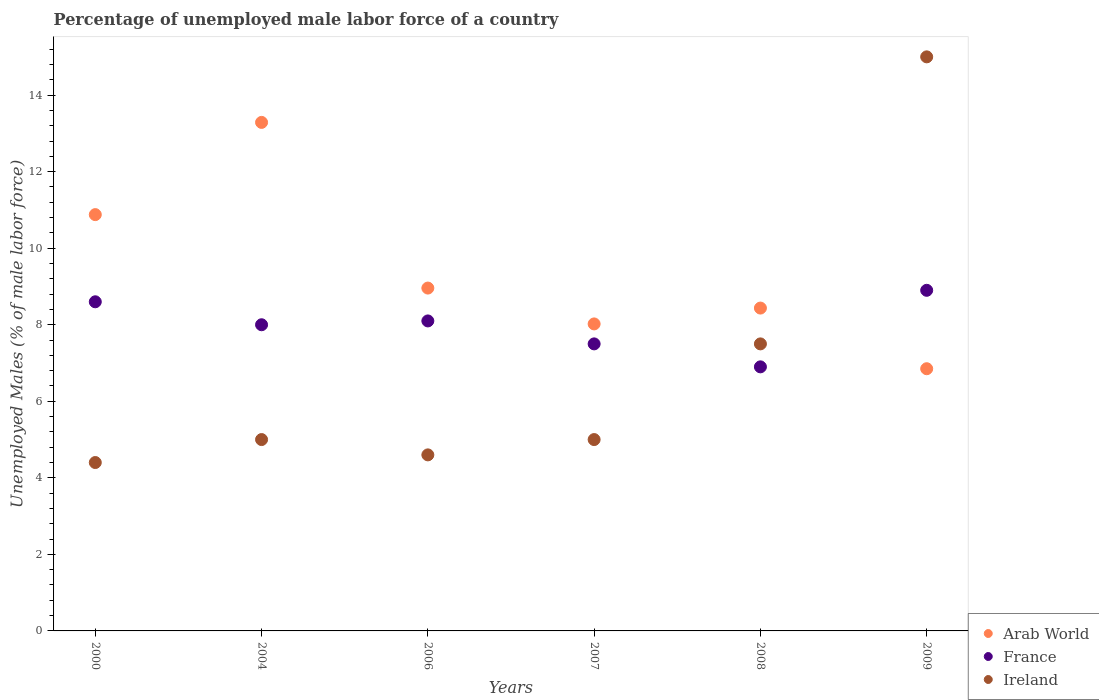How many different coloured dotlines are there?
Provide a short and direct response. 3. Is the number of dotlines equal to the number of legend labels?
Give a very brief answer. Yes. Across all years, what is the maximum percentage of unemployed male labor force in France?
Your answer should be very brief. 8.9. Across all years, what is the minimum percentage of unemployed male labor force in Ireland?
Ensure brevity in your answer.  4.4. In which year was the percentage of unemployed male labor force in Arab World maximum?
Your answer should be compact. 2004. In which year was the percentage of unemployed male labor force in Arab World minimum?
Provide a succinct answer. 2009. What is the total percentage of unemployed male labor force in Ireland in the graph?
Provide a short and direct response. 41.5. What is the difference between the percentage of unemployed male labor force in Ireland in 2000 and the percentage of unemployed male labor force in France in 2009?
Provide a short and direct response. -4.5. What is the average percentage of unemployed male labor force in Arab World per year?
Ensure brevity in your answer.  9.41. In the year 2007, what is the difference between the percentage of unemployed male labor force in Arab World and percentage of unemployed male labor force in Ireland?
Your response must be concise. 3.02. In how many years, is the percentage of unemployed male labor force in Arab World greater than 0.4 %?
Give a very brief answer. 6. What is the ratio of the percentage of unemployed male labor force in Ireland in 2004 to that in 2006?
Ensure brevity in your answer.  1.09. Is the percentage of unemployed male labor force in Ireland in 2008 less than that in 2009?
Provide a short and direct response. Yes. Is the difference between the percentage of unemployed male labor force in Arab World in 2006 and 2007 greater than the difference between the percentage of unemployed male labor force in Ireland in 2006 and 2007?
Provide a short and direct response. Yes. What is the difference between the highest and the second highest percentage of unemployed male labor force in Arab World?
Provide a succinct answer. 2.41. What is the difference between the highest and the lowest percentage of unemployed male labor force in Arab World?
Make the answer very short. 6.44. Is the sum of the percentage of unemployed male labor force in Arab World in 2000 and 2008 greater than the maximum percentage of unemployed male labor force in Ireland across all years?
Make the answer very short. Yes. Does the percentage of unemployed male labor force in France monotonically increase over the years?
Offer a terse response. No. Is the percentage of unemployed male labor force in France strictly greater than the percentage of unemployed male labor force in Ireland over the years?
Offer a very short reply. No. Is the percentage of unemployed male labor force in France strictly less than the percentage of unemployed male labor force in Ireland over the years?
Offer a very short reply. No. How many dotlines are there?
Keep it short and to the point. 3. What is the difference between two consecutive major ticks on the Y-axis?
Provide a short and direct response. 2. Where does the legend appear in the graph?
Provide a short and direct response. Bottom right. How many legend labels are there?
Your answer should be compact. 3. How are the legend labels stacked?
Ensure brevity in your answer.  Vertical. What is the title of the graph?
Provide a succinct answer. Percentage of unemployed male labor force of a country. What is the label or title of the X-axis?
Your response must be concise. Years. What is the label or title of the Y-axis?
Your response must be concise. Unemployed Males (% of male labor force). What is the Unemployed Males (% of male labor force) in Arab World in 2000?
Make the answer very short. 10.88. What is the Unemployed Males (% of male labor force) of France in 2000?
Make the answer very short. 8.6. What is the Unemployed Males (% of male labor force) of Ireland in 2000?
Make the answer very short. 4.4. What is the Unemployed Males (% of male labor force) of Arab World in 2004?
Offer a very short reply. 13.29. What is the Unemployed Males (% of male labor force) in France in 2004?
Your response must be concise. 8. What is the Unemployed Males (% of male labor force) in Ireland in 2004?
Offer a very short reply. 5. What is the Unemployed Males (% of male labor force) in Arab World in 2006?
Offer a terse response. 8.96. What is the Unemployed Males (% of male labor force) in France in 2006?
Your response must be concise. 8.1. What is the Unemployed Males (% of male labor force) in Ireland in 2006?
Offer a terse response. 4.6. What is the Unemployed Males (% of male labor force) of Arab World in 2007?
Give a very brief answer. 8.02. What is the Unemployed Males (% of male labor force) of Arab World in 2008?
Offer a very short reply. 8.44. What is the Unemployed Males (% of male labor force) of France in 2008?
Give a very brief answer. 6.9. What is the Unemployed Males (% of male labor force) of Ireland in 2008?
Provide a short and direct response. 7.5. What is the Unemployed Males (% of male labor force) of Arab World in 2009?
Keep it short and to the point. 6.85. What is the Unemployed Males (% of male labor force) of France in 2009?
Your answer should be compact. 8.9. Across all years, what is the maximum Unemployed Males (% of male labor force) of Arab World?
Keep it short and to the point. 13.29. Across all years, what is the maximum Unemployed Males (% of male labor force) of France?
Keep it short and to the point. 8.9. Across all years, what is the maximum Unemployed Males (% of male labor force) of Ireland?
Your answer should be very brief. 15. Across all years, what is the minimum Unemployed Males (% of male labor force) in Arab World?
Give a very brief answer. 6.85. Across all years, what is the minimum Unemployed Males (% of male labor force) of France?
Ensure brevity in your answer.  6.9. Across all years, what is the minimum Unemployed Males (% of male labor force) of Ireland?
Offer a terse response. 4.4. What is the total Unemployed Males (% of male labor force) in Arab World in the graph?
Your answer should be compact. 56.43. What is the total Unemployed Males (% of male labor force) in Ireland in the graph?
Give a very brief answer. 41.5. What is the difference between the Unemployed Males (% of male labor force) of Arab World in 2000 and that in 2004?
Give a very brief answer. -2.41. What is the difference between the Unemployed Males (% of male labor force) in France in 2000 and that in 2004?
Ensure brevity in your answer.  0.6. What is the difference between the Unemployed Males (% of male labor force) of Ireland in 2000 and that in 2004?
Give a very brief answer. -0.6. What is the difference between the Unemployed Males (% of male labor force) of Arab World in 2000 and that in 2006?
Offer a very short reply. 1.92. What is the difference between the Unemployed Males (% of male labor force) of Arab World in 2000 and that in 2007?
Make the answer very short. 2.86. What is the difference between the Unemployed Males (% of male labor force) in France in 2000 and that in 2007?
Offer a very short reply. 1.1. What is the difference between the Unemployed Males (% of male labor force) of Ireland in 2000 and that in 2007?
Offer a terse response. -0.6. What is the difference between the Unemployed Males (% of male labor force) in Arab World in 2000 and that in 2008?
Your response must be concise. 2.44. What is the difference between the Unemployed Males (% of male labor force) in Ireland in 2000 and that in 2008?
Provide a short and direct response. -3.1. What is the difference between the Unemployed Males (% of male labor force) in Arab World in 2000 and that in 2009?
Your answer should be very brief. 4.03. What is the difference between the Unemployed Males (% of male labor force) of France in 2000 and that in 2009?
Give a very brief answer. -0.3. What is the difference between the Unemployed Males (% of male labor force) in Ireland in 2000 and that in 2009?
Offer a terse response. -10.6. What is the difference between the Unemployed Males (% of male labor force) of Arab World in 2004 and that in 2006?
Make the answer very short. 4.33. What is the difference between the Unemployed Males (% of male labor force) of France in 2004 and that in 2006?
Offer a very short reply. -0.1. What is the difference between the Unemployed Males (% of male labor force) in Arab World in 2004 and that in 2007?
Ensure brevity in your answer.  5.27. What is the difference between the Unemployed Males (% of male labor force) in Ireland in 2004 and that in 2007?
Give a very brief answer. 0. What is the difference between the Unemployed Males (% of male labor force) of Arab World in 2004 and that in 2008?
Offer a very short reply. 4.85. What is the difference between the Unemployed Males (% of male labor force) of Arab World in 2004 and that in 2009?
Your response must be concise. 6.44. What is the difference between the Unemployed Males (% of male labor force) of France in 2004 and that in 2009?
Provide a succinct answer. -0.9. What is the difference between the Unemployed Males (% of male labor force) in Arab World in 2006 and that in 2007?
Make the answer very short. 0.94. What is the difference between the Unemployed Males (% of male labor force) of France in 2006 and that in 2007?
Your answer should be compact. 0.6. What is the difference between the Unemployed Males (% of male labor force) of Arab World in 2006 and that in 2008?
Offer a terse response. 0.52. What is the difference between the Unemployed Males (% of male labor force) of France in 2006 and that in 2008?
Offer a terse response. 1.2. What is the difference between the Unemployed Males (% of male labor force) of Ireland in 2006 and that in 2008?
Give a very brief answer. -2.9. What is the difference between the Unemployed Males (% of male labor force) of Arab World in 2006 and that in 2009?
Provide a short and direct response. 2.11. What is the difference between the Unemployed Males (% of male labor force) in Arab World in 2007 and that in 2008?
Your response must be concise. -0.41. What is the difference between the Unemployed Males (% of male labor force) of Arab World in 2007 and that in 2009?
Make the answer very short. 1.17. What is the difference between the Unemployed Males (% of male labor force) of France in 2007 and that in 2009?
Offer a very short reply. -1.4. What is the difference between the Unemployed Males (% of male labor force) of Ireland in 2007 and that in 2009?
Offer a very short reply. -10. What is the difference between the Unemployed Males (% of male labor force) in Arab World in 2008 and that in 2009?
Offer a terse response. 1.58. What is the difference between the Unemployed Males (% of male labor force) in France in 2008 and that in 2009?
Ensure brevity in your answer.  -2. What is the difference between the Unemployed Males (% of male labor force) in Arab World in 2000 and the Unemployed Males (% of male labor force) in France in 2004?
Your response must be concise. 2.88. What is the difference between the Unemployed Males (% of male labor force) in Arab World in 2000 and the Unemployed Males (% of male labor force) in Ireland in 2004?
Keep it short and to the point. 5.88. What is the difference between the Unemployed Males (% of male labor force) of Arab World in 2000 and the Unemployed Males (% of male labor force) of France in 2006?
Offer a very short reply. 2.78. What is the difference between the Unemployed Males (% of male labor force) in Arab World in 2000 and the Unemployed Males (% of male labor force) in Ireland in 2006?
Provide a succinct answer. 6.28. What is the difference between the Unemployed Males (% of male labor force) of France in 2000 and the Unemployed Males (% of male labor force) of Ireland in 2006?
Give a very brief answer. 4. What is the difference between the Unemployed Males (% of male labor force) of Arab World in 2000 and the Unemployed Males (% of male labor force) of France in 2007?
Your answer should be very brief. 3.38. What is the difference between the Unemployed Males (% of male labor force) of Arab World in 2000 and the Unemployed Males (% of male labor force) of Ireland in 2007?
Your answer should be very brief. 5.88. What is the difference between the Unemployed Males (% of male labor force) in France in 2000 and the Unemployed Males (% of male labor force) in Ireland in 2007?
Give a very brief answer. 3.6. What is the difference between the Unemployed Males (% of male labor force) of Arab World in 2000 and the Unemployed Males (% of male labor force) of France in 2008?
Your answer should be compact. 3.98. What is the difference between the Unemployed Males (% of male labor force) in Arab World in 2000 and the Unemployed Males (% of male labor force) in Ireland in 2008?
Offer a terse response. 3.38. What is the difference between the Unemployed Males (% of male labor force) in Arab World in 2000 and the Unemployed Males (% of male labor force) in France in 2009?
Keep it short and to the point. 1.98. What is the difference between the Unemployed Males (% of male labor force) of Arab World in 2000 and the Unemployed Males (% of male labor force) of Ireland in 2009?
Offer a terse response. -4.12. What is the difference between the Unemployed Males (% of male labor force) of Arab World in 2004 and the Unemployed Males (% of male labor force) of France in 2006?
Keep it short and to the point. 5.19. What is the difference between the Unemployed Males (% of male labor force) in Arab World in 2004 and the Unemployed Males (% of male labor force) in Ireland in 2006?
Keep it short and to the point. 8.69. What is the difference between the Unemployed Males (% of male labor force) in France in 2004 and the Unemployed Males (% of male labor force) in Ireland in 2006?
Your response must be concise. 3.4. What is the difference between the Unemployed Males (% of male labor force) in Arab World in 2004 and the Unemployed Males (% of male labor force) in France in 2007?
Your answer should be compact. 5.79. What is the difference between the Unemployed Males (% of male labor force) of Arab World in 2004 and the Unemployed Males (% of male labor force) of Ireland in 2007?
Your response must be concise. 8.29. What is the difference between the Unemployed Males (% of male labor force) in Arab World in 2004 and the Unemployed Males (% of male labor force) in France in 2008?
Provide a succinct answer. 6.39. What is the difference between the Unemployed Males (% of male labor force) in Arab World in 2004 and the Unemployed Males (% of male labor force) in Ireland in 2008?
Offer a terse response. 5.79. What is the difference between the Unemployed Males (% of male labor force) in Arab World in 2004 and the Unemployed Males (% of male labor force) in France in 2009?
Provide a succinct answer. 4.39. What is the difference between the Unemployed Males (% of male labor force) in Arab World in 2004 and the Unemployed Males (% of male labor force) in Ireland in 2009?
Ensure brevity in your answer.  -1.71. What is the difference between the Unemployed Males (% of male labor force) in France in 2004 and the Unemployed Males (% of male labor force) in Ireland in 2009?
Offer a very short reply. -7. What is the difference between the Unemployed Males (% of male labor force) in Arab World in 2006 and the Unemployed Males (% of male labor force) in France in 2007?
Your answer should be compact. 1.46. What is the difference between the Unemployed Males (% of male labor force) of Arab World in 2006 and the Unemployed Males (% of male labor force) of Ireland in 2007?
Give a very brief answer. 3.96. What is the difference between the Unemployed Males (% of male labor force) in France in 2006 and the Unemployed Males (% of male labor force) in Ireland in 2007?
Your answer should be compact. 3.1. What is the difference between the Unemployed Males (% of male labor force) of Arab World in 2006 and the Unemployed Males (% of male labor force) of France in 2008?
Your response must be concise. 2.06. What is the difference between the Unemployed Males (% of male labor force) in Arab World in 2006 and the Unemployed Males (% of male labor force) in Ireland in 2008?
Keep it short and to the point. 1.46. What is the difference between the Unemployed Males (% of male labor force) of Arab World in 2006 and the Unemployed Males (% of male labor force) of France in 2009?
Provide a short and direct response. 0.06. What is the difference between the Unemployed Males (% of male labor force) in Arab World in 2006 and the Unemployed Males (% of male labor force) in Ireland in 2009?
Keep it short and to the point. -6.04. What is the difference between the Unemployed Males (% of male labor force) of France in 2006 and the Unemployed Males (% of male labor force) of Ireland in 2009?
Your answer should be very brief. -6.9. What is the difference between the Unemployed Males (% of male labor force) of Arab World in 2007 and the Unemployed Males (% of male labor force) of France in 2008?
Offer a terse response. 1.12. What is the difference between the Unemployed Males (% of male labor force) in Arab World in 2007 and the Unemployed Males (% of male labor force) in Ireland in 2008?
Your answer should be compact. 0.52. What is the difference between the Unemployed Males (% of male labor force) in Arab World in 2007 and the Unemployed Males (% of male labor force) in France in 2009?
Give a very brief answer. -0.88. What is the difference between the Unemployed Males (% of male labor force) of Arab World in 2007 and the Unemployed Males (% of male labor force) of Ireland in 2009?
Offer a terse response. -6.98. What is the difference between the Unemployed Males (% of male labor force) of Arab World in 2008 and the Unemployed Males (% of male labor force) of France in 2009?
Your answer should be compact. -0.46. What is the difference between the Unemployed Males (% of male labor force) in Arab World in 2008 and the Unemployed Males (% of male labor force) in Ireland in 2009?
Give a very brief answer. -6.56. What is the average Unemployed Males (% of male labor force) of Arab World per year?
Provide a short and direct response. 9.41. What is the average Unemployed Males (% of male labor force) in France per year?
Offer a terse response. 8. What is the average Unemployed Males (% of male labor force) in Ireland per year?
Offer a terse response. 6.92. In the year 2000, what is the difference between the Unemployed Males (% of male labor force) of Arab World and Unemployed Males (% of male labor force) of France?
Offer a terse response. 2.28. In the year 2000, what is the difference between the Unemployed Males (% of male labor force) of Arab World and Unemployed Males (% of male labor force) of Ireland?
Provide a succinct answer. 6.48. In the year 2000, what is the difference between the Unemployed Males (% of male labor force) of France and Unemployed Males (% of male labor force) of Ireland?
Provide a succinct answer. 4.2. In the year 2004, what is the difference between the Unemployed Males (% of male labor force) of Arab World and Unemployed Males (% of male labor force) of France?
Provide a succinct answer. 5.29. In the year 2004, what is the difference between the Unemployed Males (% of male labor force) in Arab World and Unemployed Males (% of male labor force) in Ireland?
Offer a very short reply. 8.29. In the year 2004, what is the difference between the Unemployed Males (% of male labor force) of France and Unemployed Males (% of male labor force) of Ireland?
Your response must be concise. 3. In the year 2006, what is the difference between the Unemployed Males (% of male labor force) in Arab World and Unemployed Males (% of male labor force) in France?
Offer a very short reply. 0.86. In the year 2006, what is the difference between the Unemployed Males (% of male labor force) in Arab World and Unemployed Males (% of male labor force) in Ireland?
Offer a terse response. 4.36. In the year 2006, what is the difference between the Unemployed Males (% of male labor force) in France and Unemployed Males (% of male labor force) in Ireland?
Provide a succinct answer. 3.5. In the year 2007, what is the difference between the Unemployed Males (% of male labor force) of Arab World and Unemployed Males (% of male labor force) of France?
Keep it short and to the point. 0.52. In the year 2007, what is the difference between the Unemployed Males (% of male labor force) in Arab World and Unemployed Males (% of male labor force) in Ireland?
Provide a short and direct response. 3.02. In the year 2008, what is the difference between the Unemployed Males (% of male labor force) in Arab World and Unemployed Males (% of male labor force) in France?
Keep it short and to the point. 1.54. In the year 2008, what is the difference between the Unemployed Males (% of male labor force) of Arab World and Unemployed Males (% of male labor force) of Ireland?
Offer a very short reply. 0.94. In the year 2008, what is the difference between the Unemployed Males (% of male labor force) in France and Unemployed Males (% of male labor force) in Ireland?
Provide a succinct answer. -0.6. In the year 2009, what is the difference between the Unemployed Males (% of male labor force) of Arab World and Unemployed Males (% of male labor force) of France?
Offer a terse response. -2.05. In the year 2009, what is the difference between the Unemployed Males (% of male labor force) in Arab World and Unemployed Males (% of male labor force) in Ireland?
Offer a very short reply. -8.15. In the year 2009, what is the difference between the Unemployed Males (% of male labor force) of France and Unemployed Males (% of male labor force) of Ireland?
Your answer should be very brief. -6.1. What is the ratio of the Unemployed Males (% of male labor force) in Arab World in 2000 to that in 2004?
Provide a succinct answer. 0.82. What is the ratio of the Unemployed Males (% of male labor force) in France in 2000 to that in 2004?
Give a very brief answer. 1.07. What is the ratio of the Unemployed Males (% of male labor force) of Arab World in 2000 to that in 2006?
Offer a terse response. 1.21. What is the ratio of the Unemployed Males (% of male labor force) of France in 2000 to that in 2006?
Provide a succinct answer. 1.06. What is the ratio of the Unemployed Males (% of male labor force) in Ireland in 2000 to that in 2006?
Your answer should be compact. 0.96. What is the ratio of the Unemployed Males (% of male labor force) of Arab World in 2000 to that in 2007?
Your answer should be very brief. 1.36. What is the ratio of the Unemployed Males (% of male labor force) in France in 2000 to that in 2007?
Your response must be concise. 1.15. What is the ratio of the Unemployed Males (% of male labor force) of Arab World in 2000 to that in 2008?
Keep it short and to the point. 1.29. What is the ratio of the Unemployed Males (% of male labor force) in France in 2000 to that in 2008?
Provide a succinct answer. 1.25. What is the ratio of the Unemployed Males (% of male labor force) of Ireland in 2000 to that in 2008?
Your answer should be compact. 0.59. What is the ratio of the Unemployed Males (% of male labor force) of Arab World in 2000 to that in 2009?
Ensure brevity in your answer.  1.59. What is the ratio of the Unemployed Males (% of male labor force) of France in 2000 to that in 2009?
Offer a terse response. 0.97. What is the ratio of the Unemployed Males (% of male labor force) of Ireland in 2000 to that in 2009?
Make the answer very short. 0.29. What is the ratio of the Unemployed Males (% of male labor force) of Arab World in 2004 to that in 2006?
Give a very brief answer. 1.48. What is the ratio of the Unemployed Males (% of male labor force) of Ireland in 2004 to that in 2006?
Your response must be concise. 1.09. What is the ratio of the Unemployed Males (% of male labor force) in Arab World in 2004 to that in 2007?
Make the answer very short. 1.66. What is the ratio of the Unemployed Males (% of male labor force) in France in 2004 to that in 2007?
Your answer should be compact. 1.07. What is the ratio of the Unemployed Males (% of male labor force) in Ireland in 2004 to that in 2007?
Make the answer very short. 1. What is the ratio of the Unemployed Males (% of male labor force) of Arab World in 2004 to that in 2008?
Provide a short and direct response. 1.58. What is the ratio of the Unemployed Males (% of male labor force) of France in 2004 to that in 2008?
Offer a terse response. 1.16. What is the ratio of the Unemployed Males (% of male labor force) of Ireland in 2004 to that in 2008?
Your answer should be compact. 0.67. What is the ratio of the Unemployed Males (% of male labor force) in Arab World in 2004 to that in 2009?
Your answer should be compact. 1.94. What is the ratio of the Unemployed Males (% of male labor force) in France in 2004 to that in 2009?
Make the answer very short. 0.9. What is the ratio of the Unemployed Males (% of male labor force) in Ireland in 2004 to that in 2009?
Provide a short and direct response. 0.33. What is the ratio of the Unemployed Males (% of male labor force) of Arab World in 2006 to that in 2007?
Offer a very short reply. 1.12. What is the ratio of the Unemployed Males (% of male labor force) in Arab World in 2006 to that in 2008?
Ensure brevity in your answer.  1.06. What is the ratio of the Unemployed Males (% of male labor force) in France in 2006 to that in 2008?
Provide a succinct answer. 1.17. What is the ratio of the Unemployed Males (% of male labor force) in Ireland in 2006 to that in 2008?
Give a very brief answer. 0.61. What is the ratio of the Unemployed Males (% of male labor force) in Arab World in 2006 to that in 2009?
Your answer should be very brief. 1.31. What is the ratio of the Unemployed Males (% of male labor force) of France in 2006 to that in 2009?
Give a very brief answer. 0.91. What is the ratio of the Unemployed Males (% of male labor force) in Ireland in 2006 to that in 2009?
Provide a short and direct response. 0.31. What is the ratio of the Unemployed Males (% of male labor force) in Arab World in 2007 to that in 2008?
Provide a short and direct response. 0.95. What is the ratio of the Unemployed Males (% of male labor force) in France in 2007 to that in 2008?
Offer a terse response. 1.09. What is the ratio of the Unemployed Males (% of male labor force) of Arab World in 2007 to that in 2009?
Provide a short and direct response. 1.17. What is the ratio of the Unemployed Males (% of male labor force) in France in 2007 to that in 2009?
Ensure brevity in your answer.  0.84. What is the ratio of the Unemployed Males (% of male labor force) in Ireland in 2007 to that in 2009?
Provide a short and direct response. 0.33. What is the ratio of the Unemployed Males (% of male labor force) in Arab World in 2008 to that in 2009?
Your answer should be very brief. 1.23. What is the ratio of the Unemployed Males (% of male labor force) in France in 2008 to that in 2009?
Provide a short and direct response. 0.78. What is the difference between the highest and the second highest Unemployed Males (% of male labor force) of Arab World?
Offer a very short reply. 2.41. What is the difference between the highest and the second highest Unemployed Males (% of male labor force) of Ireland?
Give a very brief answer. 7.5. What is the difference between the highest and the lowest Unemployed Males (% of male labor force) of Arab World?
Your answer should be very brief. 6.44. What is the difference between the highest and the lowest Unemployed Males (% of male labor force) in France?
Provide a short and direct response. 2. What is the difference between the highest and the lowest Unemployed Males (% of male labor force) in Ireland?
Ensure brevity in your answer.  10.6. 